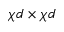Convert formula to latex. <formula><loc_0><loc_0><loc_500><loc_500>\chi d \times \chi d</formula> 